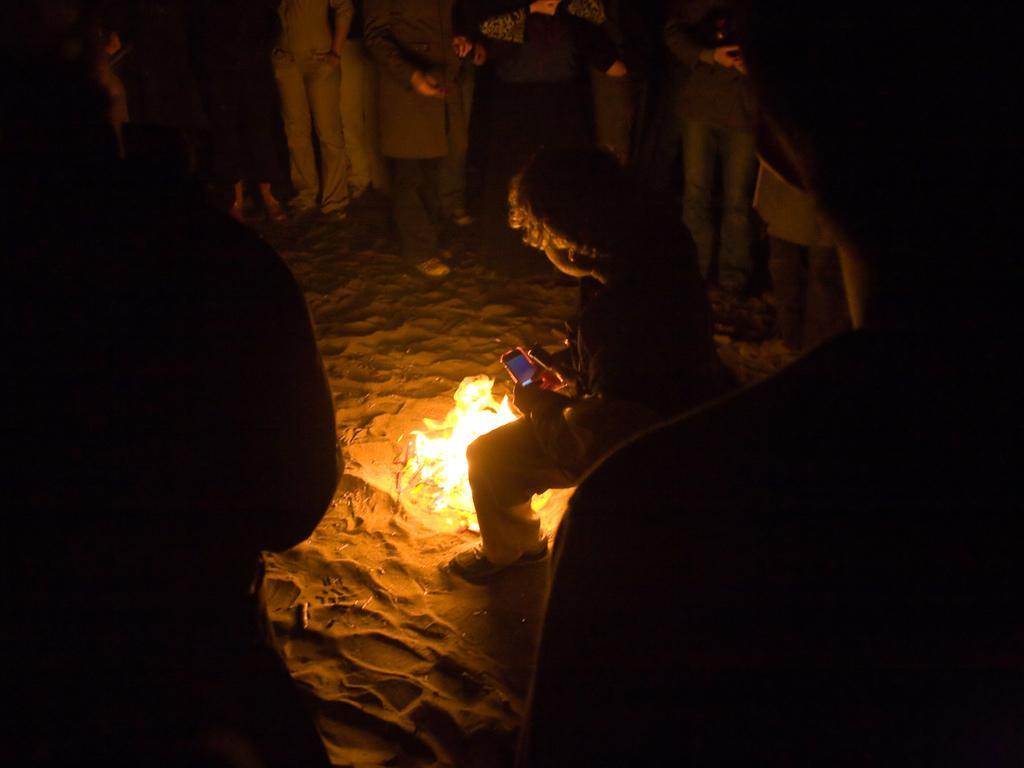In one or two sentences, can you explain what this image depicts? Many people are standing on the sand. There is fire at the center and a person is present holding a mobile phone. 